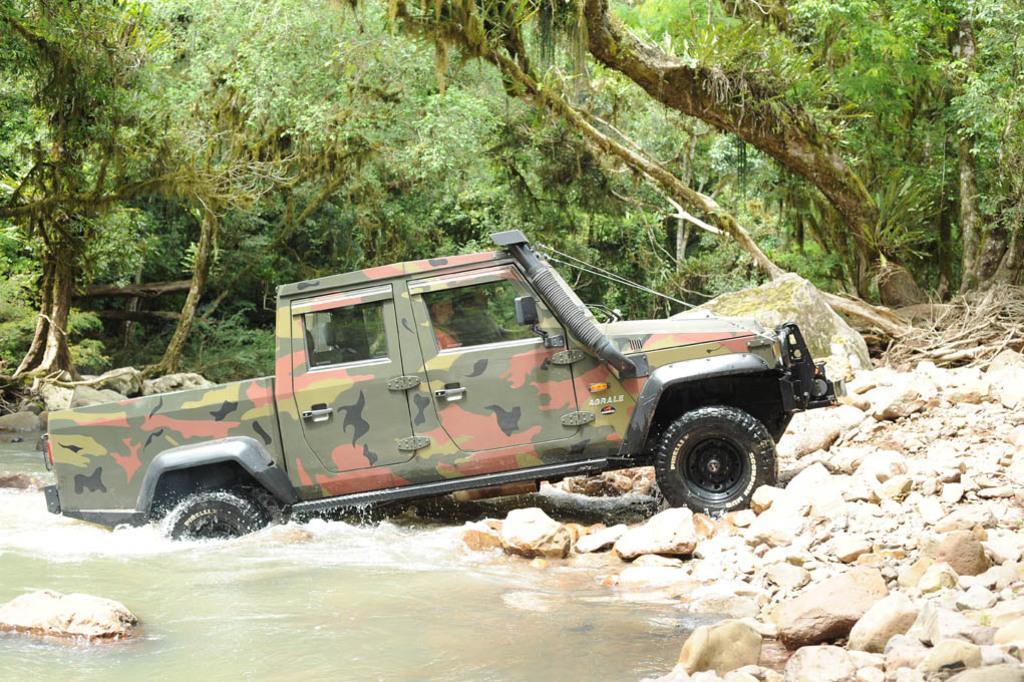Can you describe this image briefly? In this image in the center there is one vehicle, and at the bottom there is pond and some rocks. In the background there are trees and some grass. 